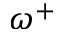<formula> <loc_0><loc_0><loc_500><loc_500>\omega ^ { + }</formula> 